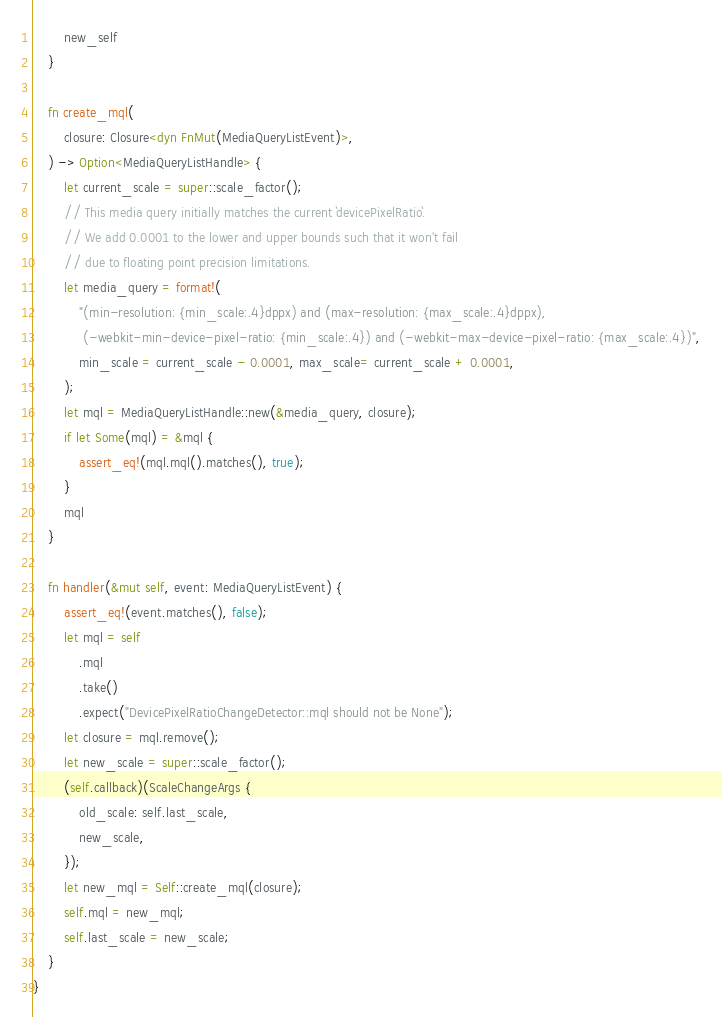<code> <loc_0><loc_0><loc_500><loc_500><_Rust_>        new_self
    }

    fn create_mql(
        closure: Closure<dyn FnMut(MediaQueryListEvent)>,
    ) -> Option<MediaQueryListHandle> {
        let current_scale = super::scale_factor();
        // This media query initially matches the current `devicePixelRatio`.
        // We add 0.0001 to the lower and upper bounds such that it won't fail
        // due to floating point precision limitations.
        let media_query = format!(
            "(min-resolution: {min_scale:.4}dppx) and (max-resolution: {max_scale:.4}dppx),
             (-webkit-min-device-pixel-ratio: {min_scale:.4}) and (-webkit-max-device-pixel-ratio: {max_scale:.4})",
            min_scale = current_scale - 0.0001, max_scale= current_scale + 0.0001,
        );
        let mql = MediaQueryListHandle::new(&media_query, closure);
        if let Some(mql) = &mql {
            assert_eq!(mql.mql().matches(), true);
        }
        mql
    }

    fn handler(&mut self, event: MediaQueryListEvent) {
        assert_eq!(event.matches(), false);
        let mql = self
            .mql
            .take()
            .expect("DevicePixelRatioChangeDetector::mql should not be None");
        let closure = mql.remove();
        let new_scale = super::scale_factor();
        (self.callback)(ScaleChangeArgs {
            old_scale: self.last_scale,
            new_scale,
        });
        let new_mql = Self::create_mql(closure);
        self.mql = new_mql;
        self.last_scale = new_scale;
    }
}
</code> 